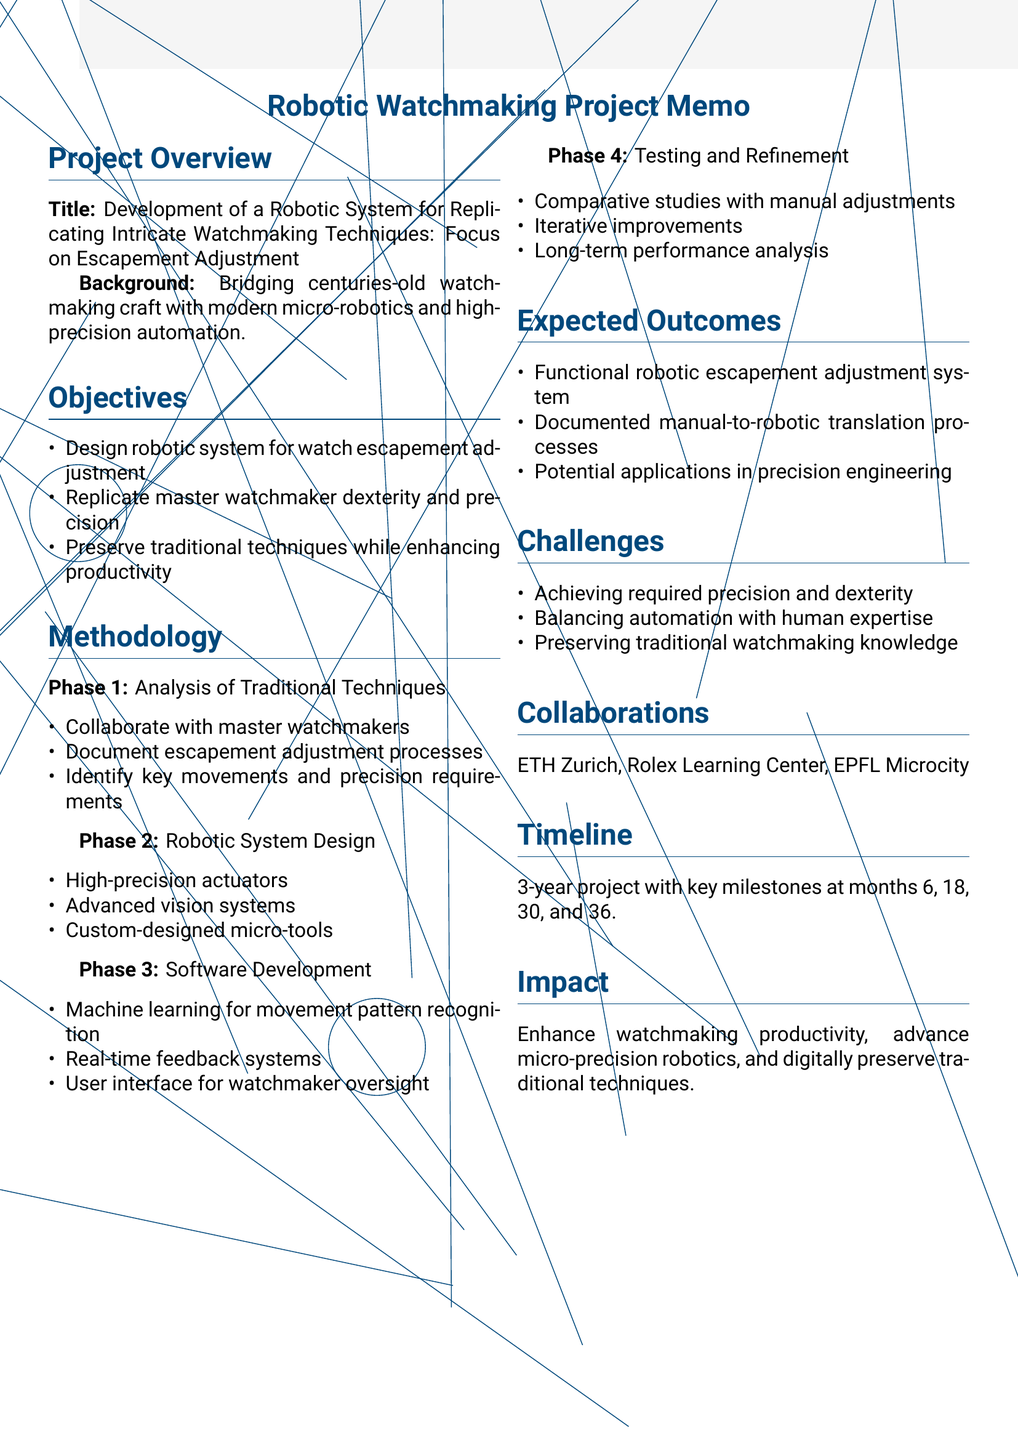What is the project title? The project title is provided at the beginning of the document.
Answer: Development of a Robotic System for Replicating Intricate Watchmaking Techniques: Focus on Escapement Adjustment How long is the project duration? The duration of the project is stated in the timeline section of the document.
Answer: 3 years What is the first phase of the methodology? The document outlines four phases of the methodology, starting with the first phase.
Answer: Analysis of Traditional Techniques Which companies are mentioned for collaboration in the document? The document lists collaborations with specific organizations relevant to the project.
Answer: Swiss Federal Institute of Technology, Rolex Learning Center, EPFL Microcity What is one expected outcome of the project? The document lists several expected outcomes of the project.
Answer: A functional robotic system capable of adjusting watch escapements What is a potential challenge mentioned in the project? The document outlines several challenges the project may face.
Answer: Achieving the required level of precision and dexterity What type of actuators are proposed for the robotic system design? Details about the components of the robotic system are specified in the methodology section.
Answer: High-precision actuators What feature is included in the software development phase? Features of the software development phase are described in the document.
Answer: Machine learning algorithms for movement pattern recognition What milestone is set for month 30? The timeline includes major milestones associated with specific timeframes.
Answer: Software integration and initial testing 